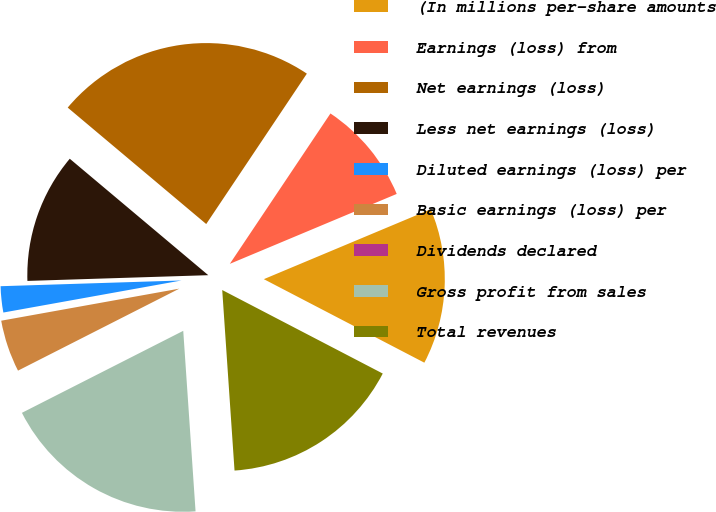Convert chart. <chart><loc_0><loc_0><loc_500><loc_500><pie_chart><fcel>(In millions per-share amounts<fcel>Earnings (loss) from<fcel>Net earnings (loss)<fcel>Less net earnings (loss)<fcel>Diluted earnings (loss) per<fcel>Basic earnings (loss) per<fcel>Dividends declared<fcel>Gross profit from sales<fcel>Total revenues<nl><fcel>13.95%<fcel>9.3%<fcel>23.26%<fcel>11.63%<fcel>2.33%<fcel>4.65%<fcel>0.0%<fcel>18.6%<fcel>16.28%<nl></chart> 